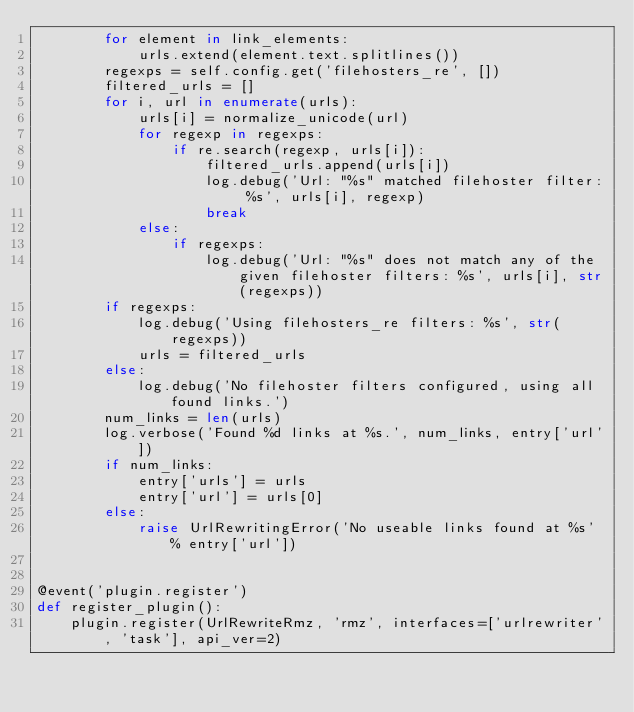<code> <loc_0><loc_0><loc_500><loc_500><_Python_>        for element in link_elements:
            urls.extend(element.text.splitlines())
        regexps = self.config.get('filehosters_re', [])
        filtered_urls = []
        for i, url in enumerate(urls):
            urls[i] = normalize_unicode(url)
            for regexp in regexps:
                if re.search(regexp, urls[i]):
                    filtered_urls.append(urls[i])
                    log.debug('Url: "%s" matched filehoster filter: %s', urls[i], regexp)
                    break
            else:
                if regexps:
                    log.debug('Url: "%s" does not match any of the given filehoster filters: %s', urls[i], str(regexps))
        if regexps:
            log.debug('Using filehosters_re filters: %s', str(regexps))
            urls = filtered_urls
        else:
            log.debug('No filehoster filters configured, using all found links.')
        num_links = len(urls)
        log.verbose('Found %d links at %s.', num_links, entry['url'])
        if num_links:
            entry['urls'] = urls
            entry['url'] = urls[0]
        else:
            raise UrlRewritingError('No useable links found at %s' % entry['url'])


@event('plugin.register')
def register_plugin():
    plugin.register(UrlRewriteRmz, 'rmz', interfaces=['urlrewriter', 'task'], api_ver=2)
</code> 